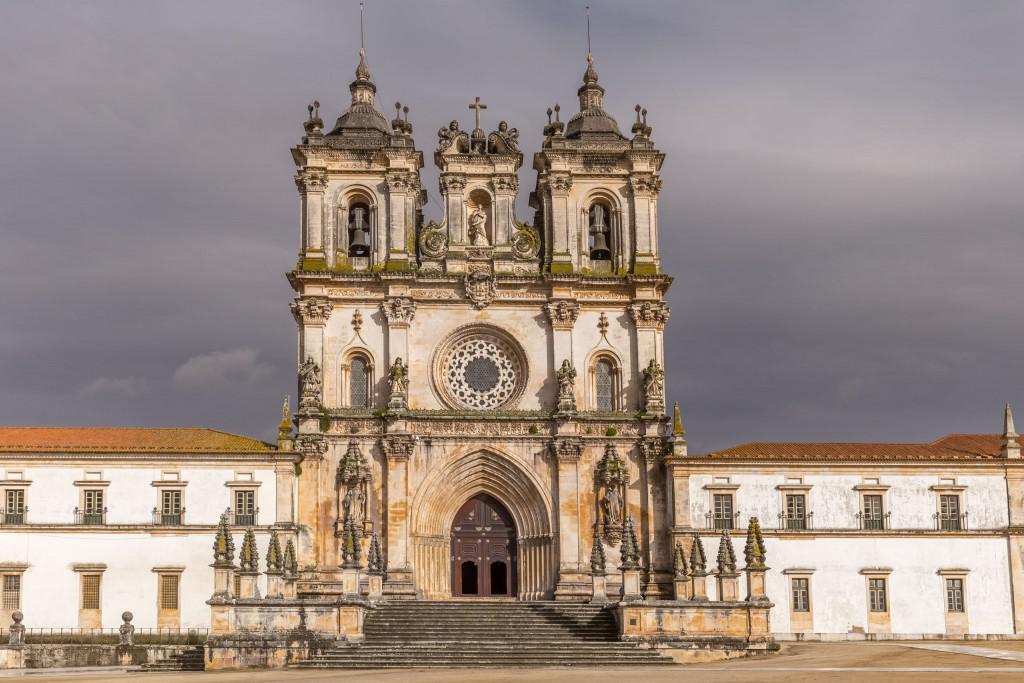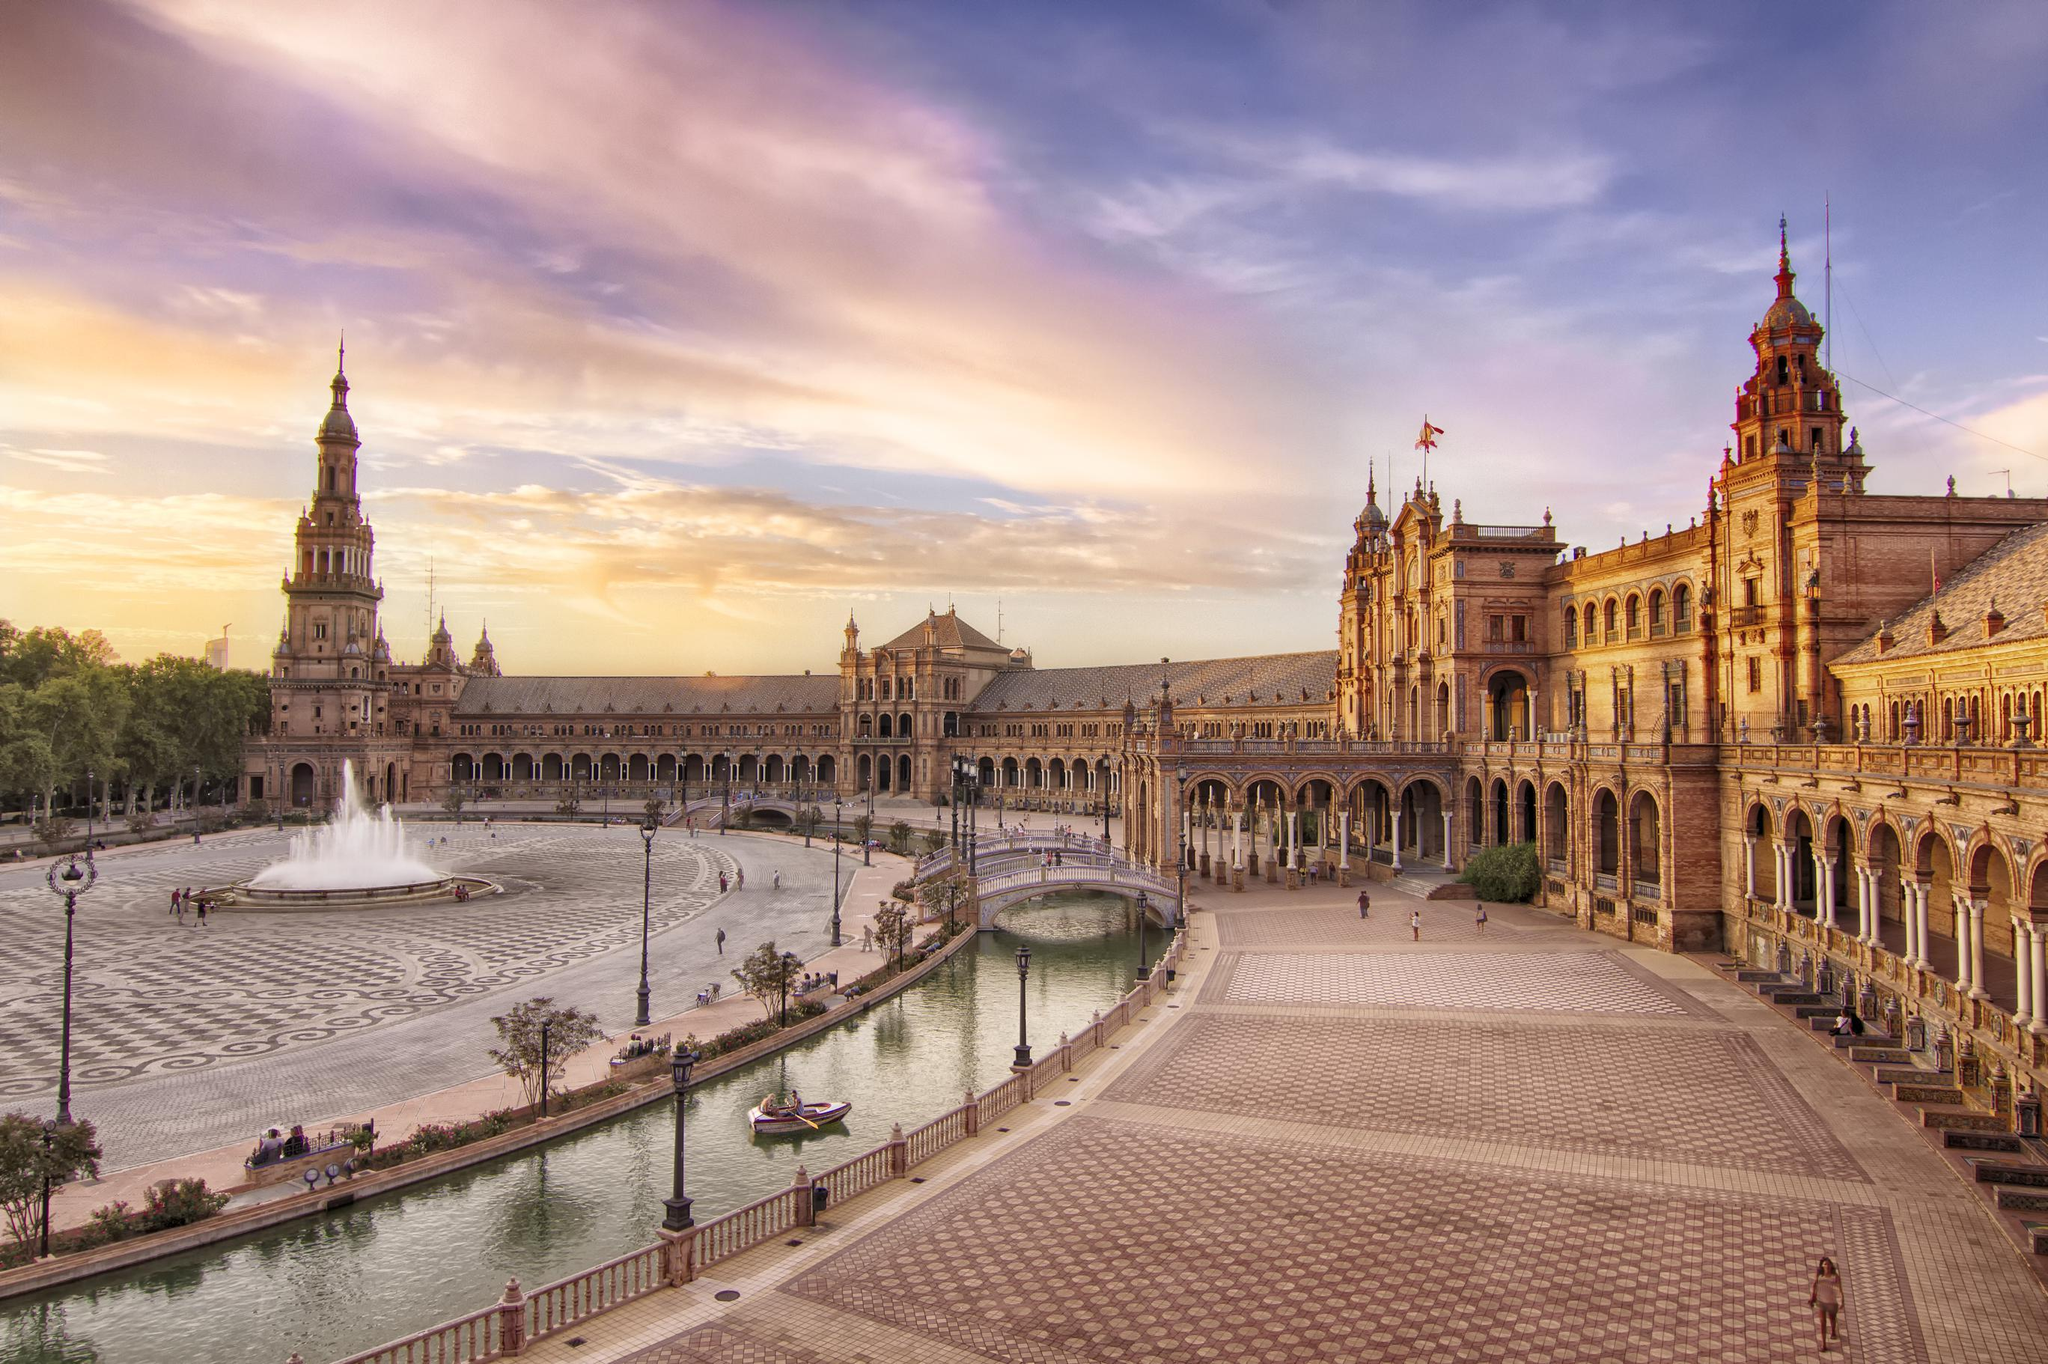The first image is the image on the left, the second image is the image on the right. Considering the images on both sides, is "There is a round window on top of the main door of a cathedral in the left image." valid? Answer yes or no. Yes. 